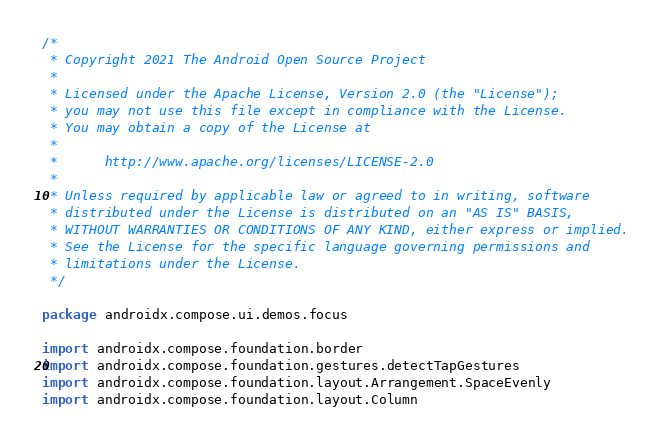<code> <loc_0><loc_0><loc_500><loc_500><_Kotlin_>/*
 * Copyright 2021 The Android Open Source Project
 *
 * Licensed under the Apache License, Version 2.0 (the "License");
 * you may not use this file except in compliance with the License.
 * You may obtain a copy of the License at
 *
 *      http://www.apache.org/licenses/LICENSE-2.0
 *
 * Unless required by applicable law or agreed to in writing, software
 * distributed under the License is distributed on an "AS IS" BASIS,
 * WITHOUT WARRANTIES OR CONDITIONS OF ANY KIND, either express or implied.
 * See the License for the specific language governing permissions and
 * limitations under the License.
 */

package androidx.compose.ui.demos.focus

import androidx.compose.foundation.border
import androidx.compose.foundation.gestures.detectTapGestures
import androidx.compose.foundation.layout.Arrangement.SpaceEvenly
import androidx.compose.foundation.layout.Column</code> 